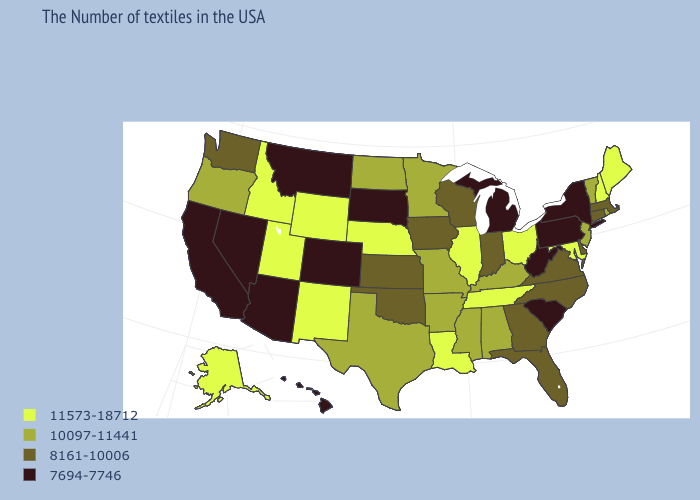Among the states that border Oregon , which have the highest value?
Write a very short answer. Idaho. What is the value of New Mexico?
Quick response, please. 11573-18712. What is the highest value in the South ?
Write a very short answer. 11573-18712. Name the states that have a value in the range 7694-7746?
Give a very brief answer. New York, Pennsylvania, South Carolina, West Virginia, Michigan, South Dakota, Colorado, Montana, Arizona, Nevada, California, Hawaii. Does Maine have a lower value than Missouri?
Write a very short answer. No. Name the states that have a value in the range 8161-10006?
Give a very brief answer. Massachusetts, Connecticut, Delaware, Virginia, North Carolina, Florida, Georgia, Indiana, Wisconsin, Iowa, Kansas, Oklahoma, Washington. Name the states that have a value in the range 10097-11441?
Keep it brief. Rhode Island, Vermont, New Jersey, Kentucky, Alabama, Mississippi, Missouri, Arkansas, Minnesota, Texas, North Dakota, Oregon. How many symbols are there in the legend?
Concise answer only. 4. Name the states that have a value in the range 8161-10006?
Short answer required. Massachusetts, Connecticut, Delaware, Virginia, North Carolina, Florida, Georgia, Indiana, Wisconsin, Iowa, Kansas, Oklahoma, Washington. Which states have the highest value in the USA?
Be succinct. Maine, New Hampshire, Maryland, Ohio, Tennessee, Illinois, Louisiana, Nebraska, Wyoming, New Mexico, Utah, Idaho, Alaska. Which states have the lowest value in the South?
Answer briefly. South Carolina, West Virginia. Which states have the lowest value in the South?
Be succinct. South Carolina, West Virginia. What is the highest value in the USA?
Short answer required. 11573-18712. Does the map have missing data?
Keep it brief. No. 